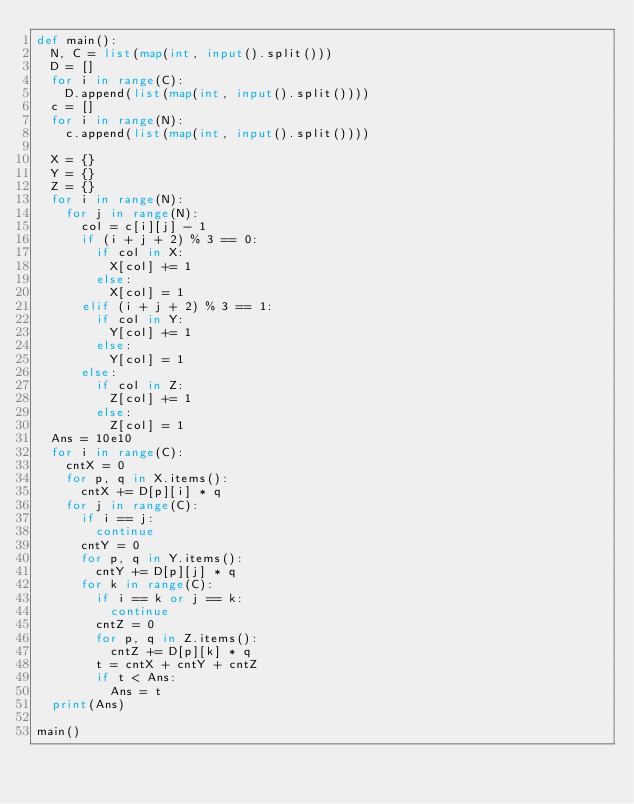Convert code to text. <code><loc_0><loc_0><loc_500><loc_500><_Python_>def main():
  N, C = list(map(int, input().split()))
  D = []
  for i in range(C):
    D.append(list(map(int, input().split())))
  c = []
  for i in range(N):
    c.append(list(map(int, input().split())))
  
  X = {}
  Y = {}
  Z = {}
  for i in range(N):
    for j in range(N):
      col = c[i][j] - 1
      if (i + j + 2) % 3 == 0:
        if col in X:
          X[col] += 1
        else:
          X[col] = 1
      elif (i + j + 2) % 3 == 1:
        if col in Y:
          Y[col] += 1
        else:
          Y[col] = 1
      else:
        if col in Z:
          Z[col] += 1
        else:
          Z[col] = 1
  Ans = 10e10      
  for i in range(C):
    cntX = 0
    for p, q in X.items():
      cntX += D[p][i] * q
    for j in range(C):
      if i == j:
        continue
      cntY = 0
      for p, q in Y.items():
        cntY += D[p][j] * q
      for k in range(C):
        if i == k or j == k:
          continue
        cntZ = 0
        for p, q in Z.items():
          cntZ += D[p][k] * q
        t = cntX + cntY + cntZ
        if t < Ans:
          Ans = t    
  print(Ans)

main()</code> 